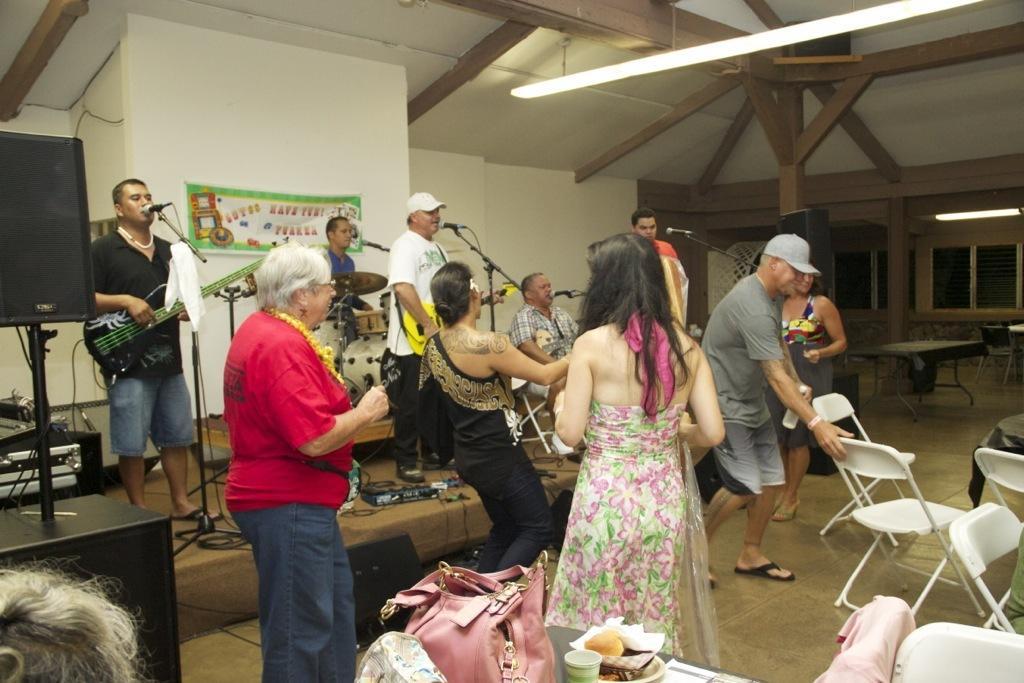Can you describe this image briefly? In this image I can see number of people are standing. I can also see few of them are holding guitars and one is sitting next to a drum set. Here I can see few chairs, tables and a bag. 